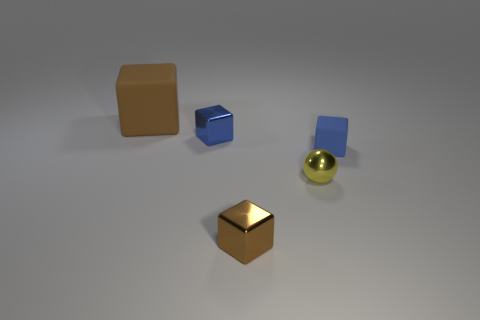What number of small things are metal spheres or brown cylinders?
Ensure brevity in your answer.  1. There is a yellow thing that is the same size as the blue shiny object; what is its shape?
Provide a short and direct response. Sphere. Are there any other things that are the same size as the brown rubber thing?
Ensure brevity in your answer.  No. There is a blue object right of the tiny blue metallic block that is behind the yellow ball; what is it made of?
Offer a terse response. Rubber. Is the ball the same size as the brown metallic block?
Ensure brevity in your answer.  Yes. How many objects are tiny blue shiny things that are left of the blue rubber thing or big purple metal spheres?
Your response must be concise. 1. What is the shape of the small metal object that is behind the tiny yellow shiny sphere to the right of the blue metallic block?
Offer a terse response. Cube. Is the size of the yellow thing the same as the matte block that is on the left side of the yellow object?
Your answer should be very brief. No. There is a blue cube that is to the right of the brown shiny block; what is it made of?
Give a very brief answer. Rubber. How many rubber things are behind the small blue shiny block and in front of the blue shiny object?
Make the answer very short. 0. 